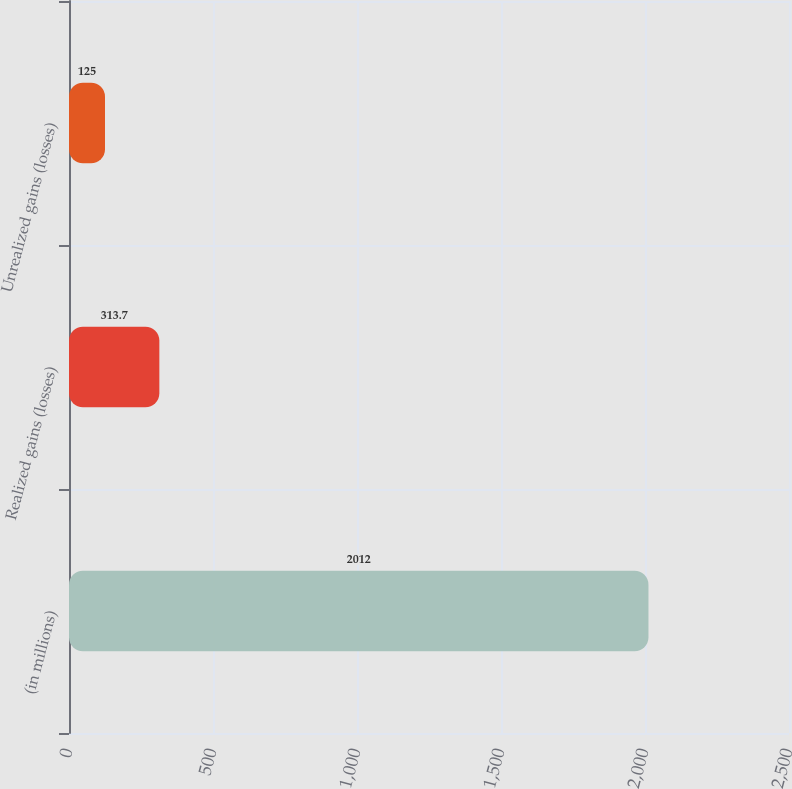<chart> <loc_0><loc_0><loc_500><loc_500><bar_chart><fcel>(in millions)<fcel>Realized gains (losses)<fcel>Unrealized gains (losses)<nl><fcel>2012<fcel>313.7<fcel>125<nl></chart> 